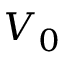<formula> <loc_0><loc_0><loc_500><loc_500>V _ { 0 }</formula> 